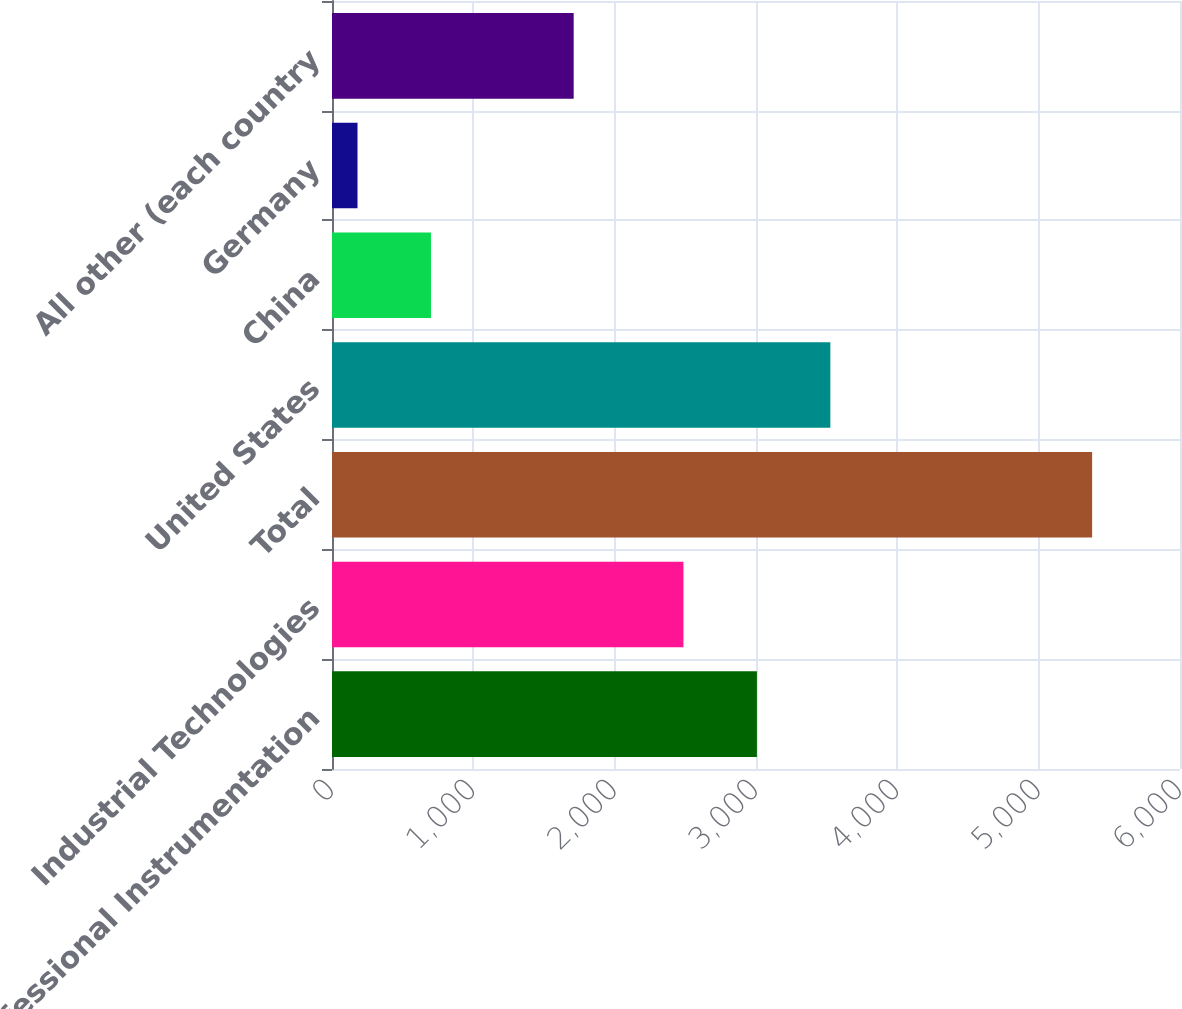<chart> <loc_0><loc_0><loc_500><loc_500><bar_chart><fcel>Professional Instrumentation<fcel>Industrial Technologies<fcel>Total<fcel>United States<fcel>China<fcel>Germany<fcel>All other (each country<nl><fcel>3006.37<fcel>2486.6<fcel>5378.2<fcel>3526.14<fcel>700.27<fcel>180.5<fcel>1710<nl></chart> 